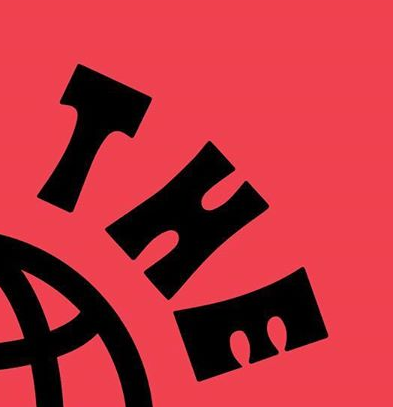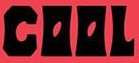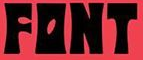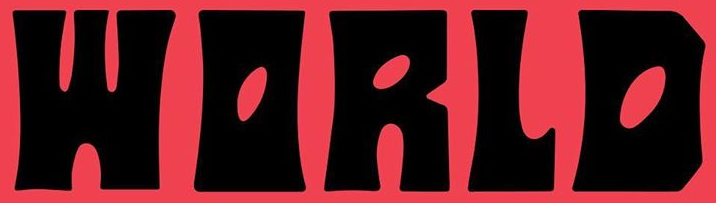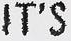What words can you see in these images in sequence, separated by a semicolon? THE; COOL; FONT; WORLD; IT'S 